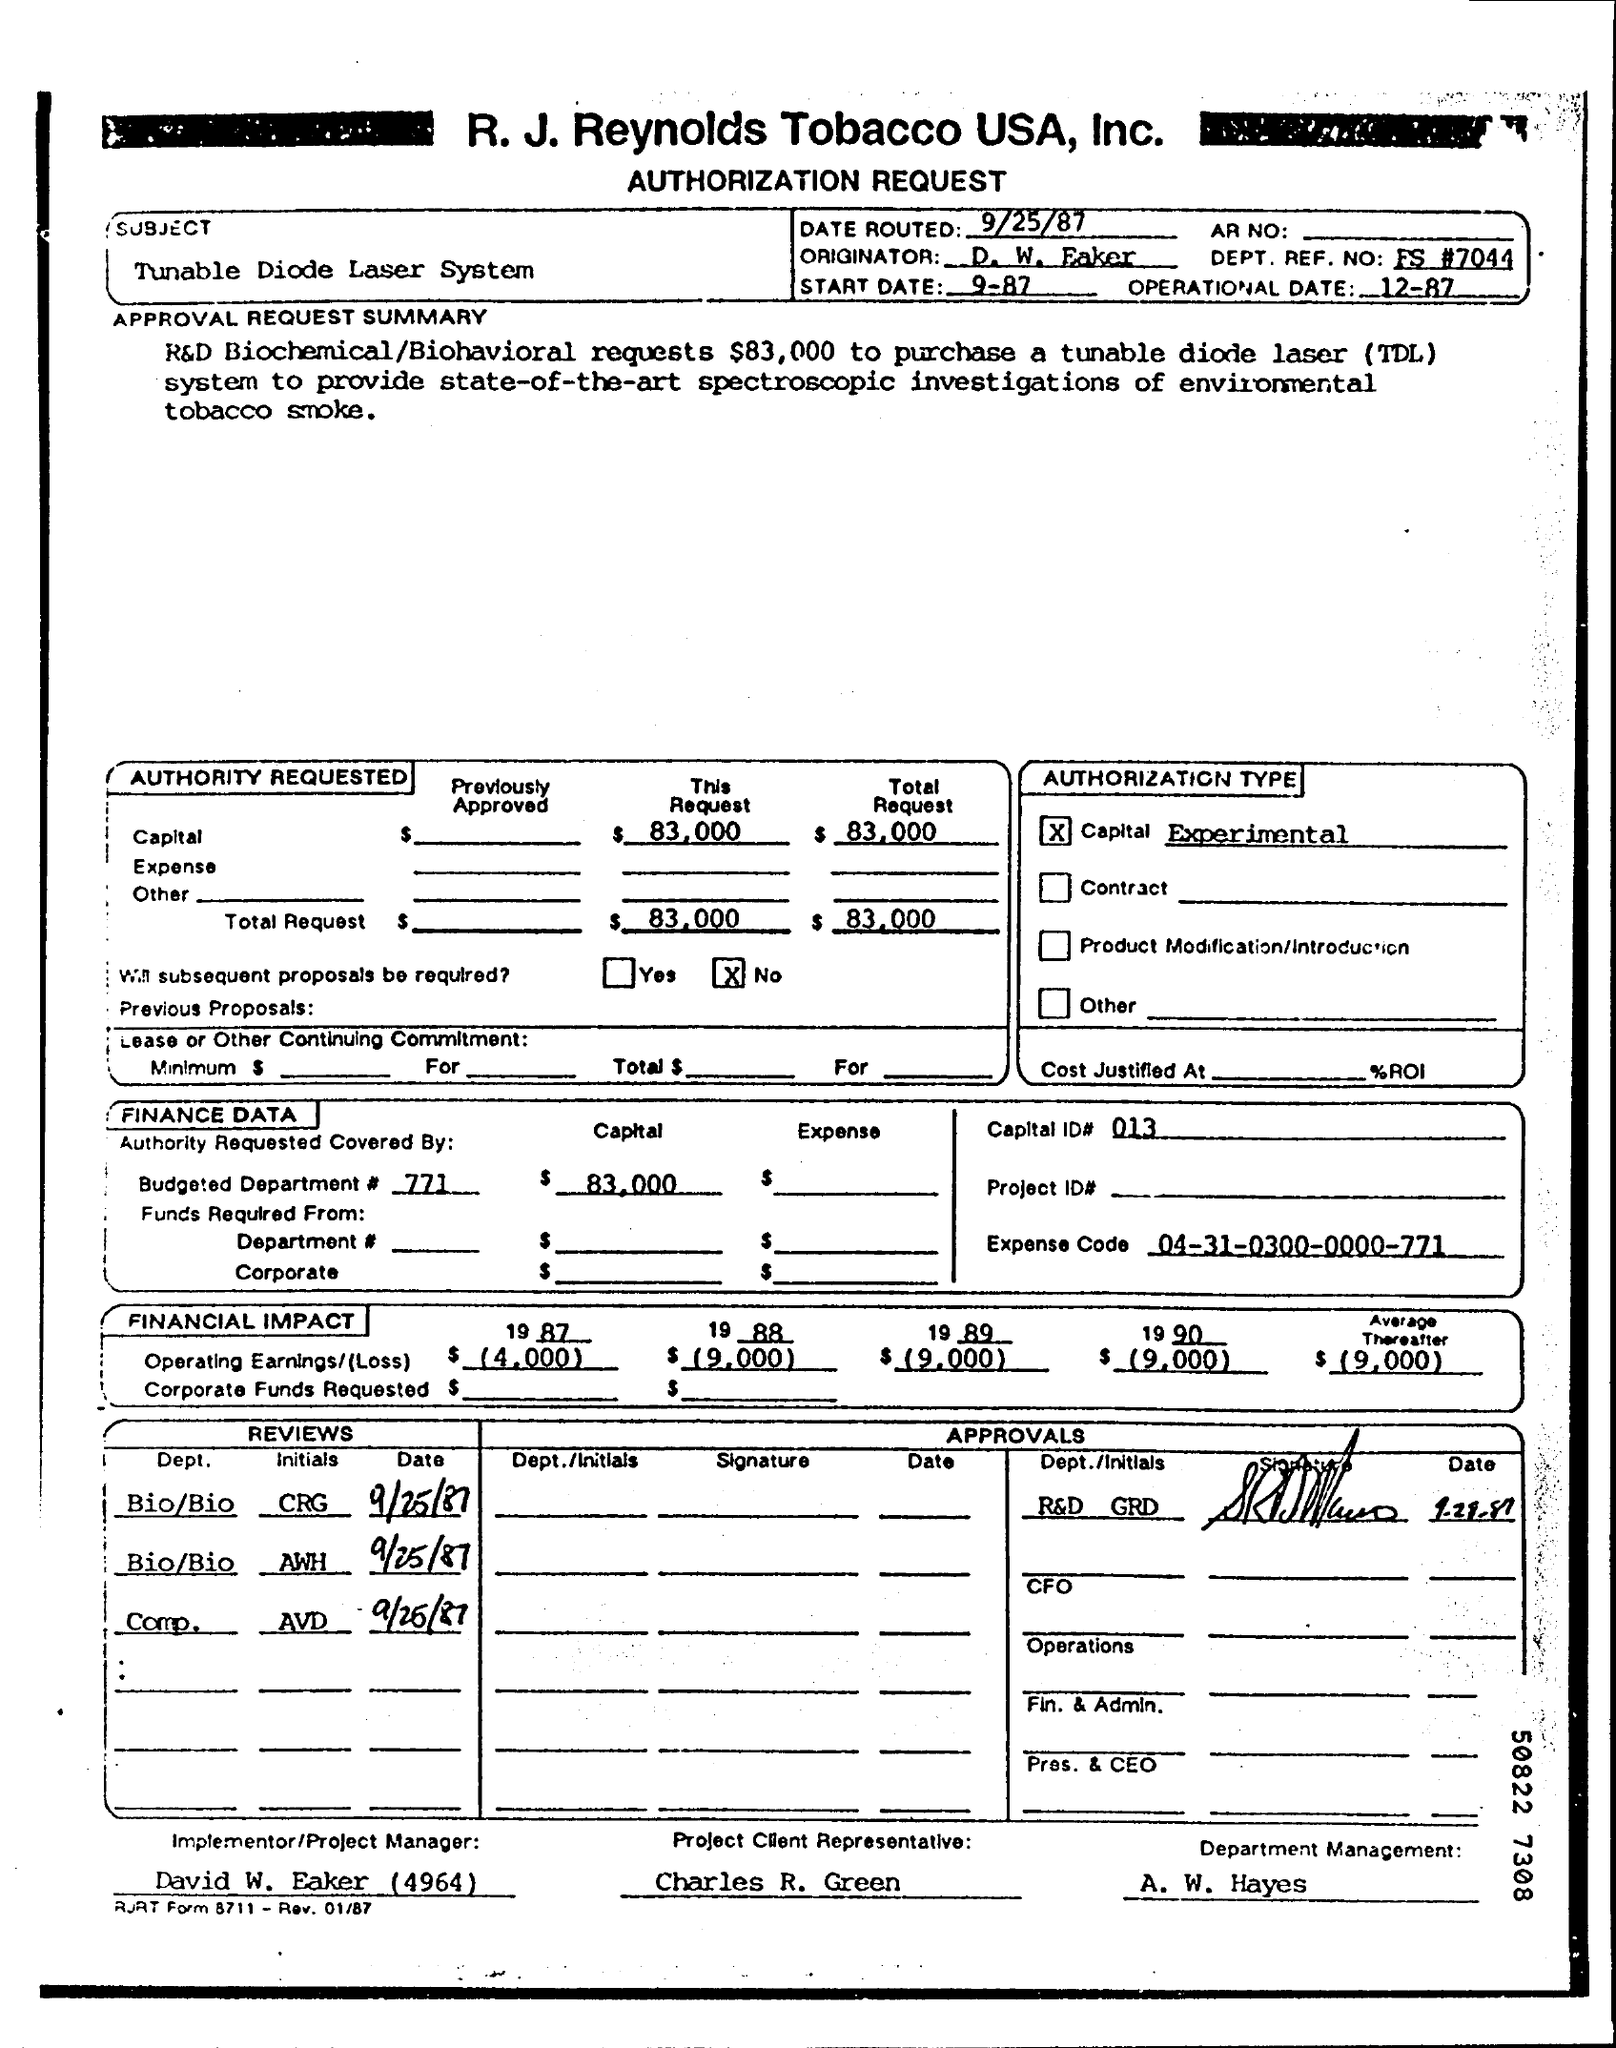Give some essential details in this illustration. The amount requested to purchase a TDL is 83,000. The client representative for the project is Charles R. Green. The subject of the Authorization request is the Tunable Diode Laser system. The date that was routed is September 25, 1987. Tunable Diode Laser, or TDL, refers to a type of laser that is capable of being adjusted to produce a specific wavelength of light. 